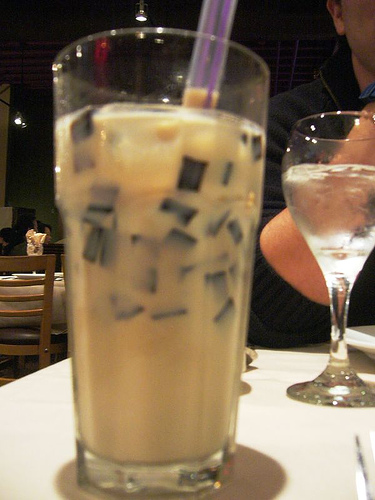<image>
Is there a glass in front of the man? Yes. The glass is positioned in front of the man, appearing closer to the camera viewpoint. 